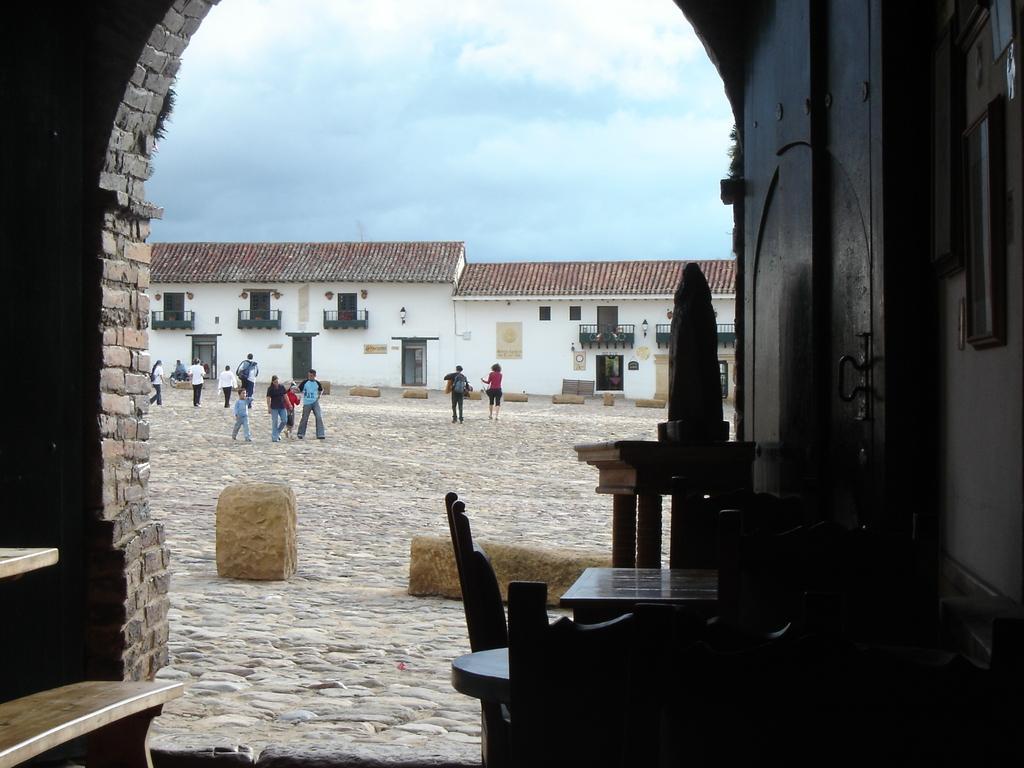How would you summarize this image in a sentence or two? As we can see in the image there are houses, windows, doors, few people here and there, sand and on the top there is a sky. 